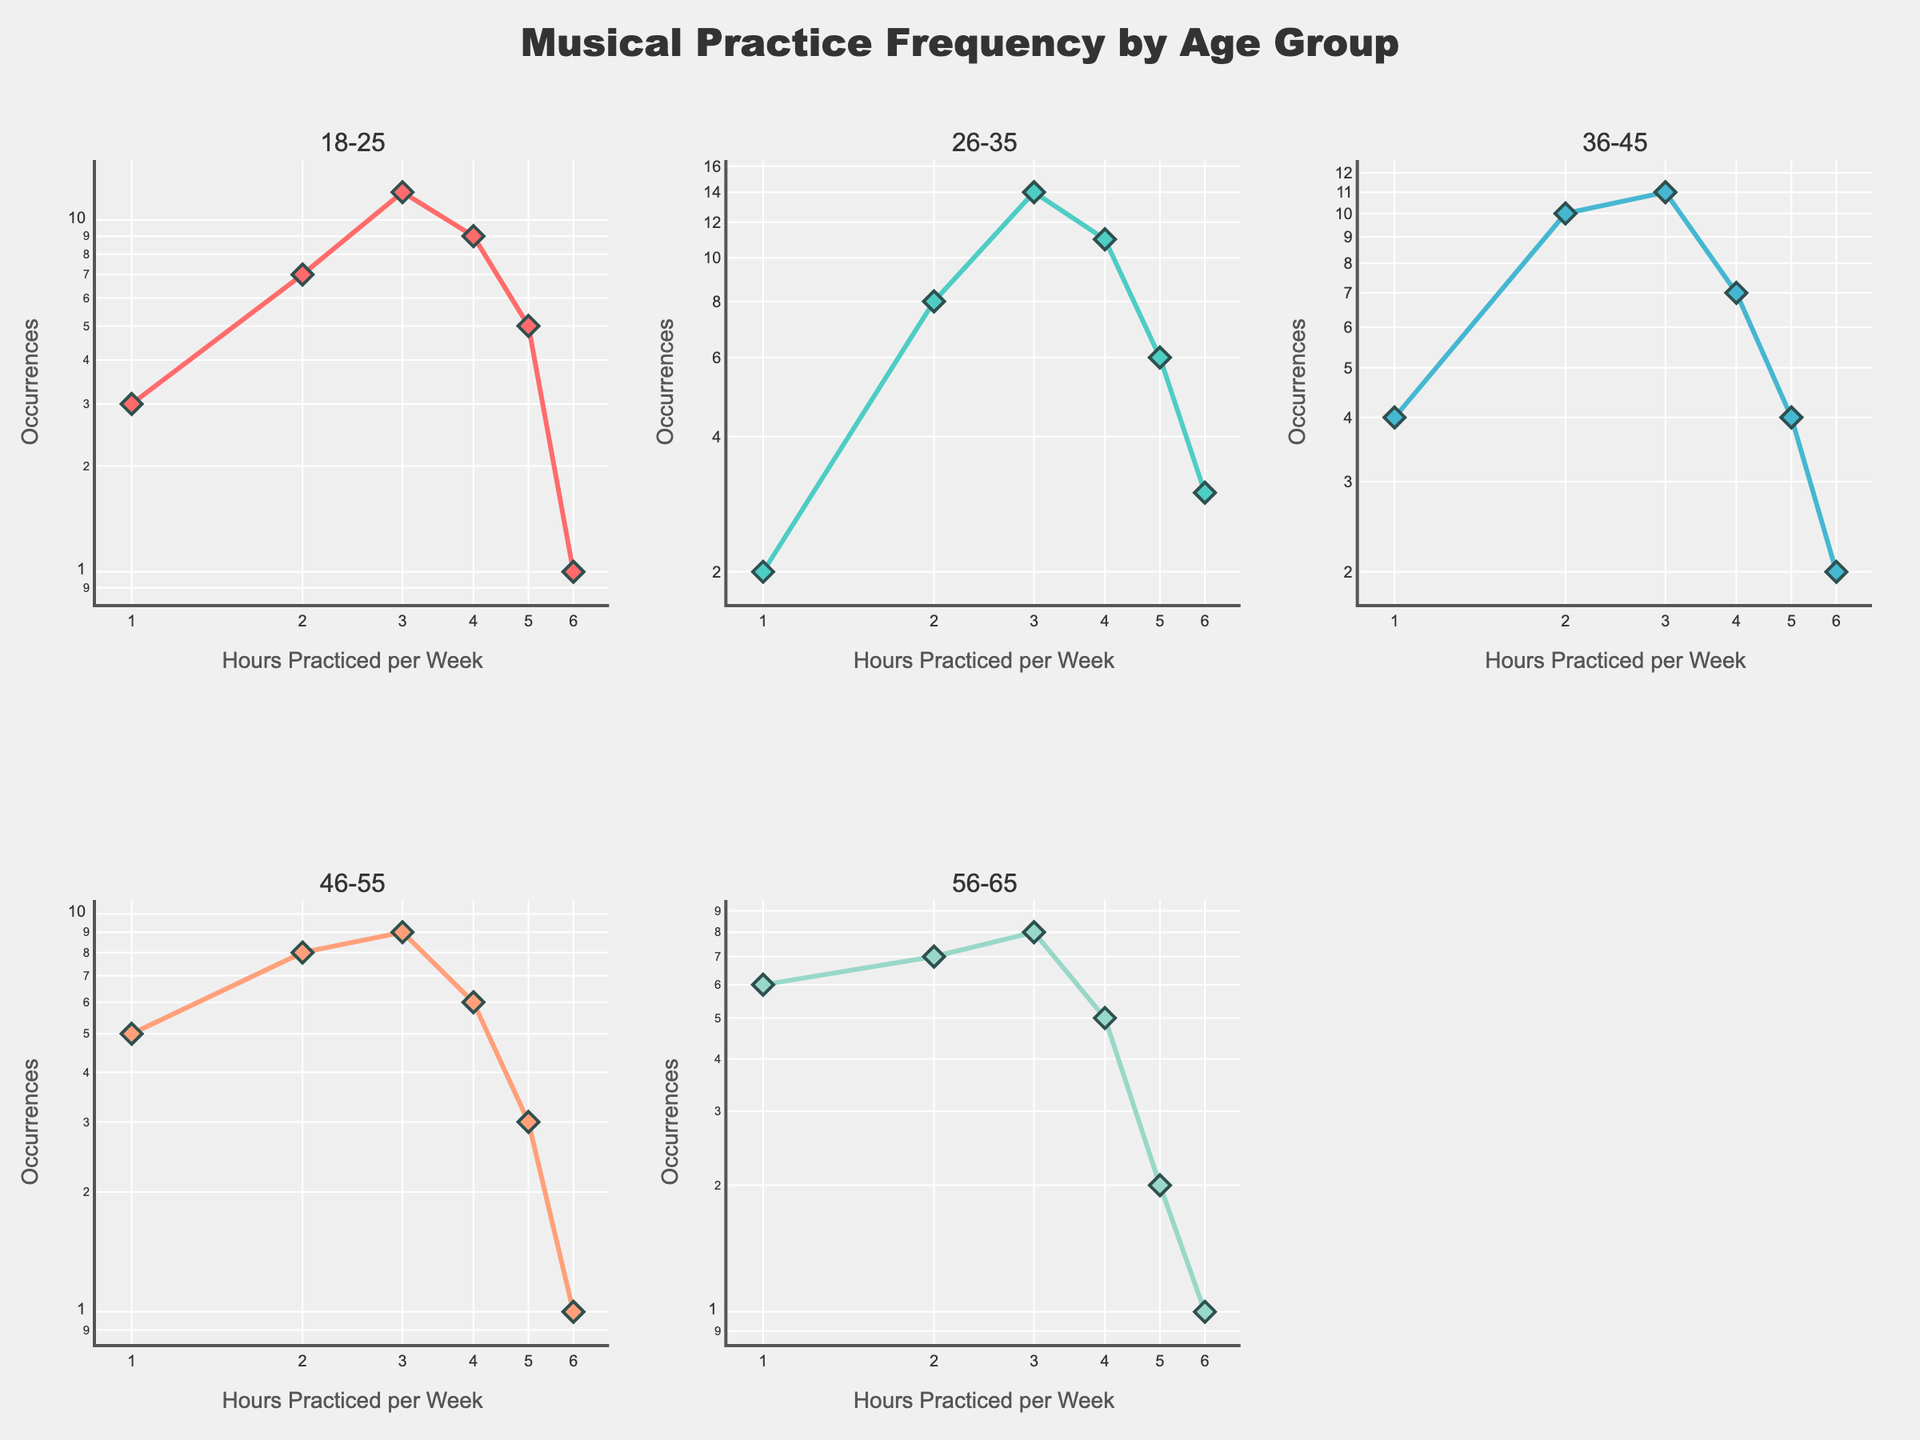what does the figure subtitle reveal? The subtitle of the figure shows it "Musical Practice Frequency by Age Group," indicating that it presents how often different age groups practice music.
Answer: Musical Practice Frequency by Age Group what information do the x-axes and y-axes convey? The x-axes represent the "Hours Practiced per Week," and the y-axes show the "Occurrences," with both being plotted on a logarithmic scale to better illustrate the distribution of the data.
Answer: Hours Practiced per Week and Occurrences Which age group practices music for 3 hours per week most frequently? By checking the peak values at 3 hours of practice per week, you can see that the 26-35 age group has the highest occurrence (14) compared to other age groups.
Answer: 26-35 Which age group has the least occurrences for practicing 6 hours per week? By examining the subplots, the age group 18-25 and 46-55 both have the fewest occurrences (1) for practicing 6 hours per week.
Answer: 18-25 and 46-55 Do any of the age groups have equal occurrences for practicing 2 hours and 4 hours per week? For the 46-55 age group, the occurrences for practicing 2 hours and 4 hours per week are equal, both are 8.
Answer: 46-55 What's the highest number of occurrences for the 36-45 age group? To find the highest number of occurrences, check the y-values for the 36-45 age group and identify the highest value, which is 11.
Answer: 11 Which age group has the most diverse range of occurrences? The 26-35 age group displays the most diverse range, as occurrences vary from 2 up to 14, indicating a broad spread of practice frequencies.
Answer: 26-35 How many subplots does the figure contain and why is this the case? The figure consists of 5 subplots, one for each age group (18-25, 26-35, 36-45, 46-55, and 56-65). This allows a side-by-side comparison of musical practice frequencies across different age groups.
Answer: 5 